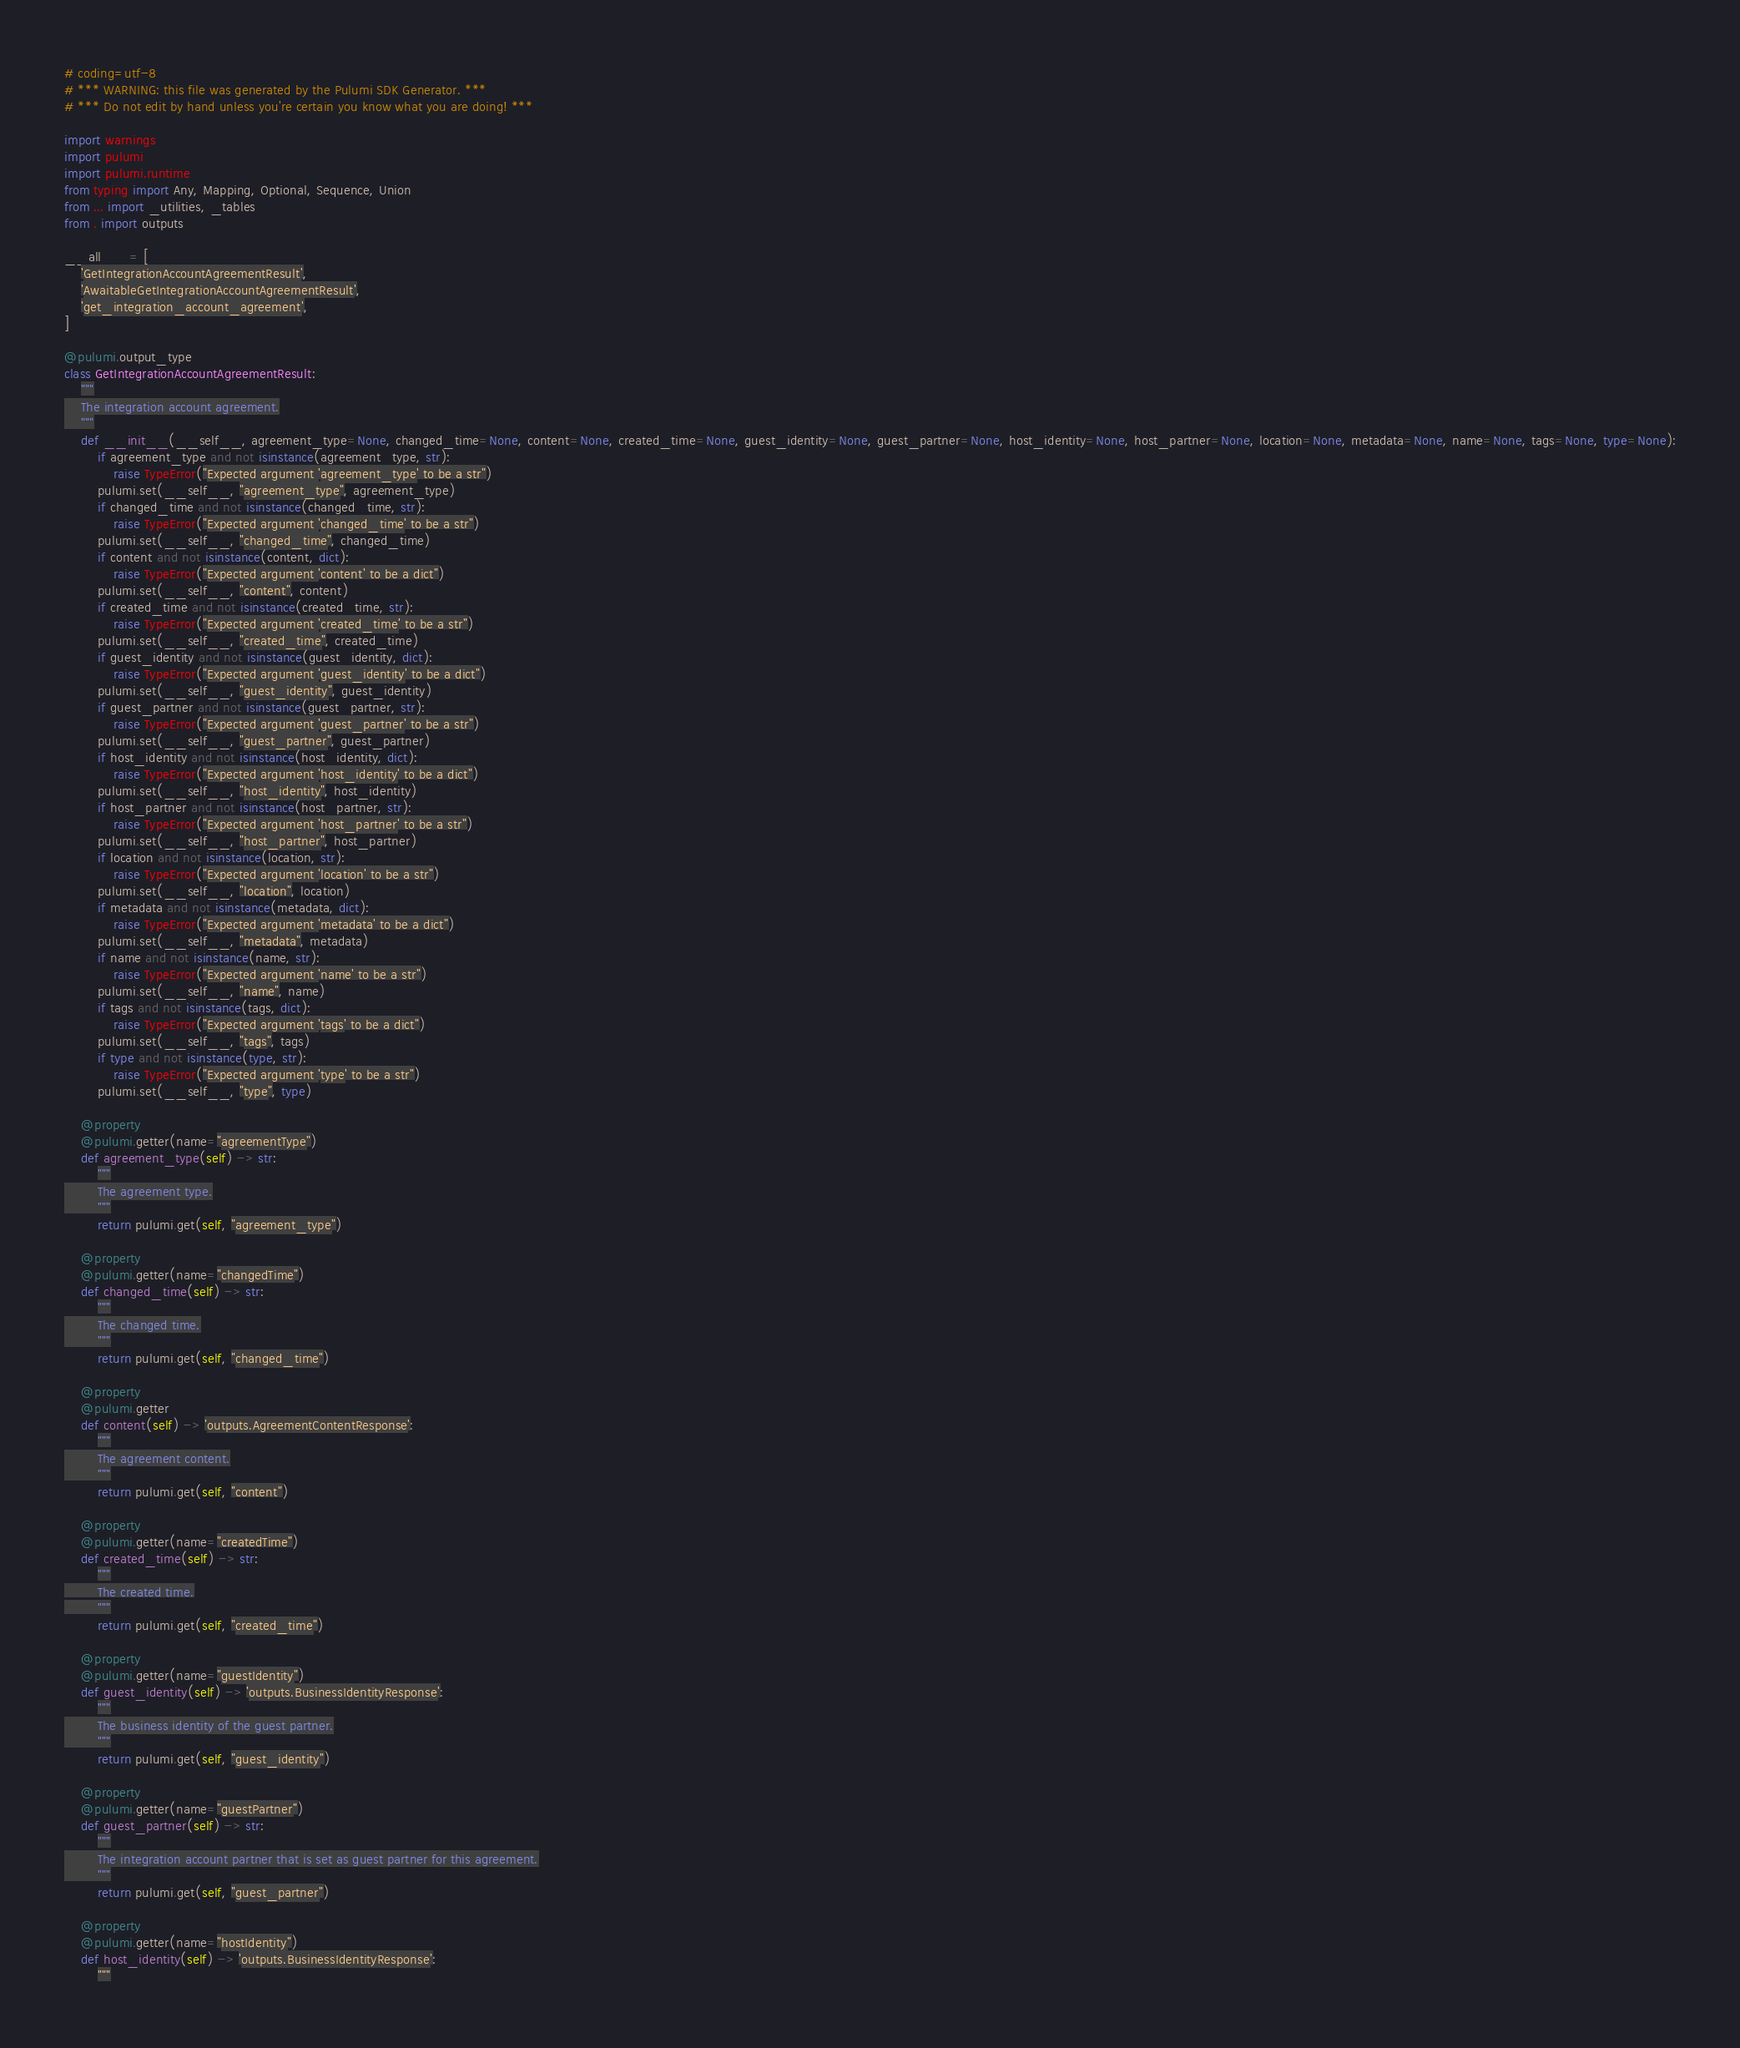<code> <loc_0><loc_0><loc_500><loc_500><_Python_># coding=utf-8
# *** WARNING: this file was generated by the Pulumi SDK Generator. ***
# *** Do not edit by hand unless you're certain you know what you are doing! ***

import warnings
import pulumi
import pulumi.runtime
from typing import Any, Mapping, Optional, Sequence, Union
from ... import _utilities, _tables
from . import outputs

__all__ = [
    'GetIntegrationAccountAgreementResult',
    'AwaitableGetIntegrationAccountAgreementResult',
    'get_integration_account_agreement',
]

@pulumi.output_type
class GetIntegrationAccountAgreementResult:
    """
    The integration account agreement.
    """
    def __init__(__self__, agreement_type=None, changed_time=None, content=None, created_time=None, guest_identity=None, guest_partner=None, host_identity=None, host_partner=None, location=None, metadata=None, name=None, tags=None, type=None):
        if agreement_type and not isinstance(agreement_type, str):
            raise TypeError("Expected argument 'agreement_type' to be a str")
        pulumi.set(__self__, "agreement_type", agreement_type)
        if changed_time and not isinstance(changed_time, str):
            raise TypeError("Expected argument 'changed_time' to be a str")
        pulumi.set(__self__, "changed_time", changed_time)
        if content and not isinstance(content, dict):
            raise TypeError("Expected argument 'content' to be a dict")
        pulumi.set(__self__, "content", content)
        if created_time and not isinstance(created_time, str):
            raise TypeError("Expected argument 'created_time' to be a str")
        pulumi.set(__self__, "created_time", created_time)
        if guest_identity and not isinstance(guest_identity, dict):
            raise TypeError("Expected argument 'guest_identity' to be a dict")
        pulumi.set(__self__, "guest_identity", guest_identity)
        if guest_partner and not isinstance(guest_partner, str):
            raise TypeError("Expected argument 'guest_partner' to be a str")
        pulumi.set(__self__, "guest_partner", guest_partner)
        if host_identity and not isinstance(host_identity, dict):
            raise TypeError("Expected argument 'host_identity' to be a dict")
        pulumi.set(__self__, "host_identity", host_identity)
        if host_partner and not isinstance(host_partner, str):
            raise TypeError("Expected argument 'host_partner' to be a str")
        pulumi.set(__self__, "host_partner", host_partner)
        if location and not isinstance(location, str):
            raise TypeError("Expected argument 'location' to be a str")
        pulumi.set(__self__, "location", location)
        if metadata and not isinstance(metadata, dict):
            raise TypeError("Expected argument 'metadata' to be a dict")
        pulumi.set(__self__, "metadata", metadata)
        if name and not isinstance(name, str):
            raise TypeError("Expected argument 'name' to be a str")
        pulumi.set(__self__, "name", name)
        if tags and not isinstance(tags, dict):
            raise TypeError("Expected argument 'tags' to be a dict")
        pulumi.set(__self__, "tags", tags)
        if type and not isinstance(type, str):
            raise TypeError("Expected argument 'type' to be a str")
        pulumi.set(__self__, "type", type)

    @property
    @pulumi.getter(name="agreementType")
    def agreement_type(self) -> str:
        """
        The agreement type.
        """
        return pulumi.get(self, "agreement_type")

    @property
    @pulumi.getter(name="changedTime")
    def changed_time(self) -> str:
        """
        The changed time.
        """
        return pulumi.get(self, "changed_time")

    @property
    @pulumi.getter
    def content(self) -> 'outputs.AgreementContentResponse':
        """
        The agreement content.
        """
        return pulumi.get(self, "content")

    @property
    @pulumi.getter(name="createdTime")
    def created_time(self) -> str:
        """
        The created time.
        """
        return pulumi.get(self, "created_time")

    @property
    @pulumi.getter(name="guestIdentity")
    def guest_identity(self) -> 'outputs.BusinessIdentityResponse':
        """
        The business identity of the guest partner.
        """
        return pulumi.get(self, "guest_identity")

    @property
    @pulumi.getter(name="guestPartner")
    def guest_partner(self) -> str:
        """
        The integration account partner that is set as guest partner for this agreement.
        """
        return pulumi.get(self, "guest_partner")

    @property
    @pulumi.getter(name="hostIdentity")
    def host_identity(self) -> 'outputs.BusinessIdentityResponse':
        """</code> 